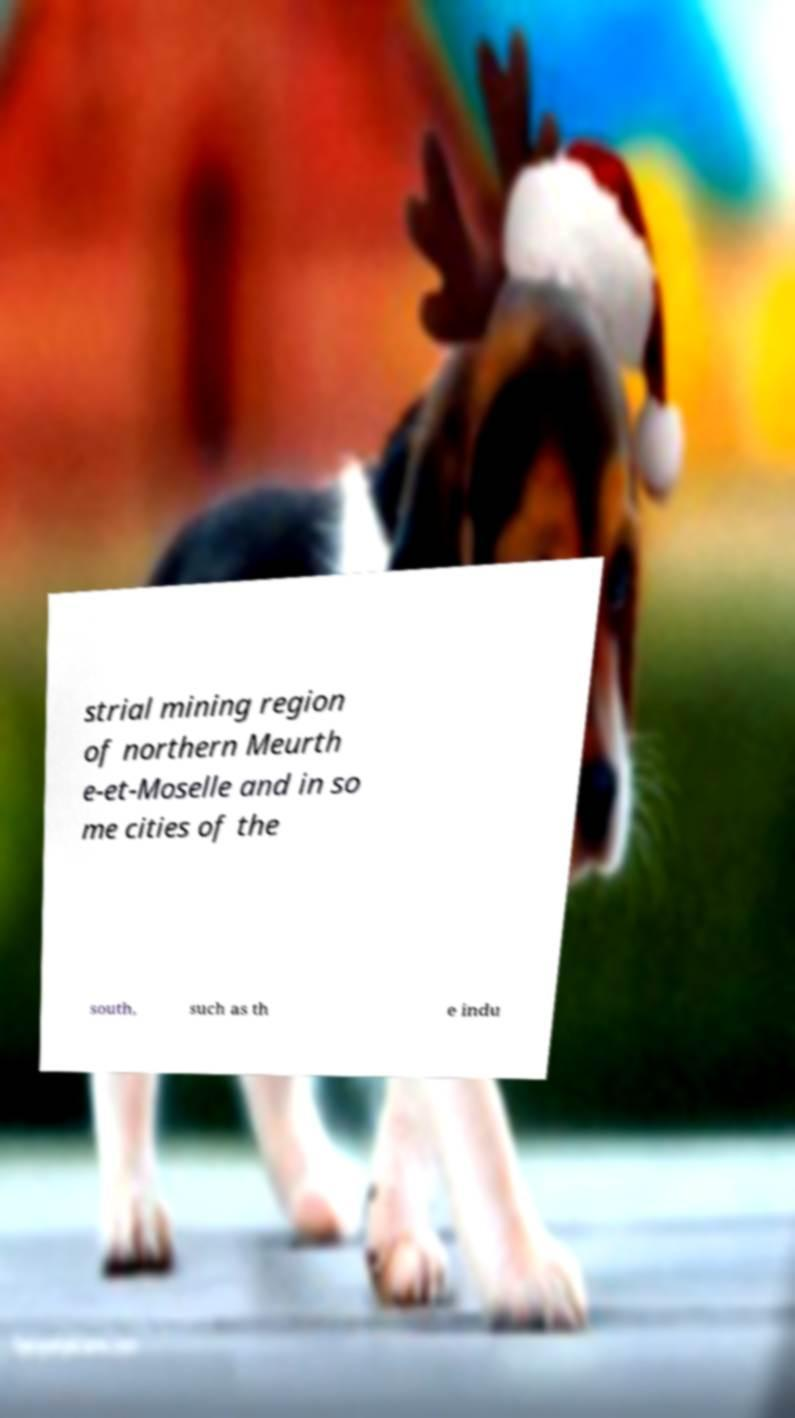Could you assist in decoding the text presented in this image and type it out clearly? strial mining region of northern Meurth e-et-Moselle and in so me cities of the south, such as th e indu 